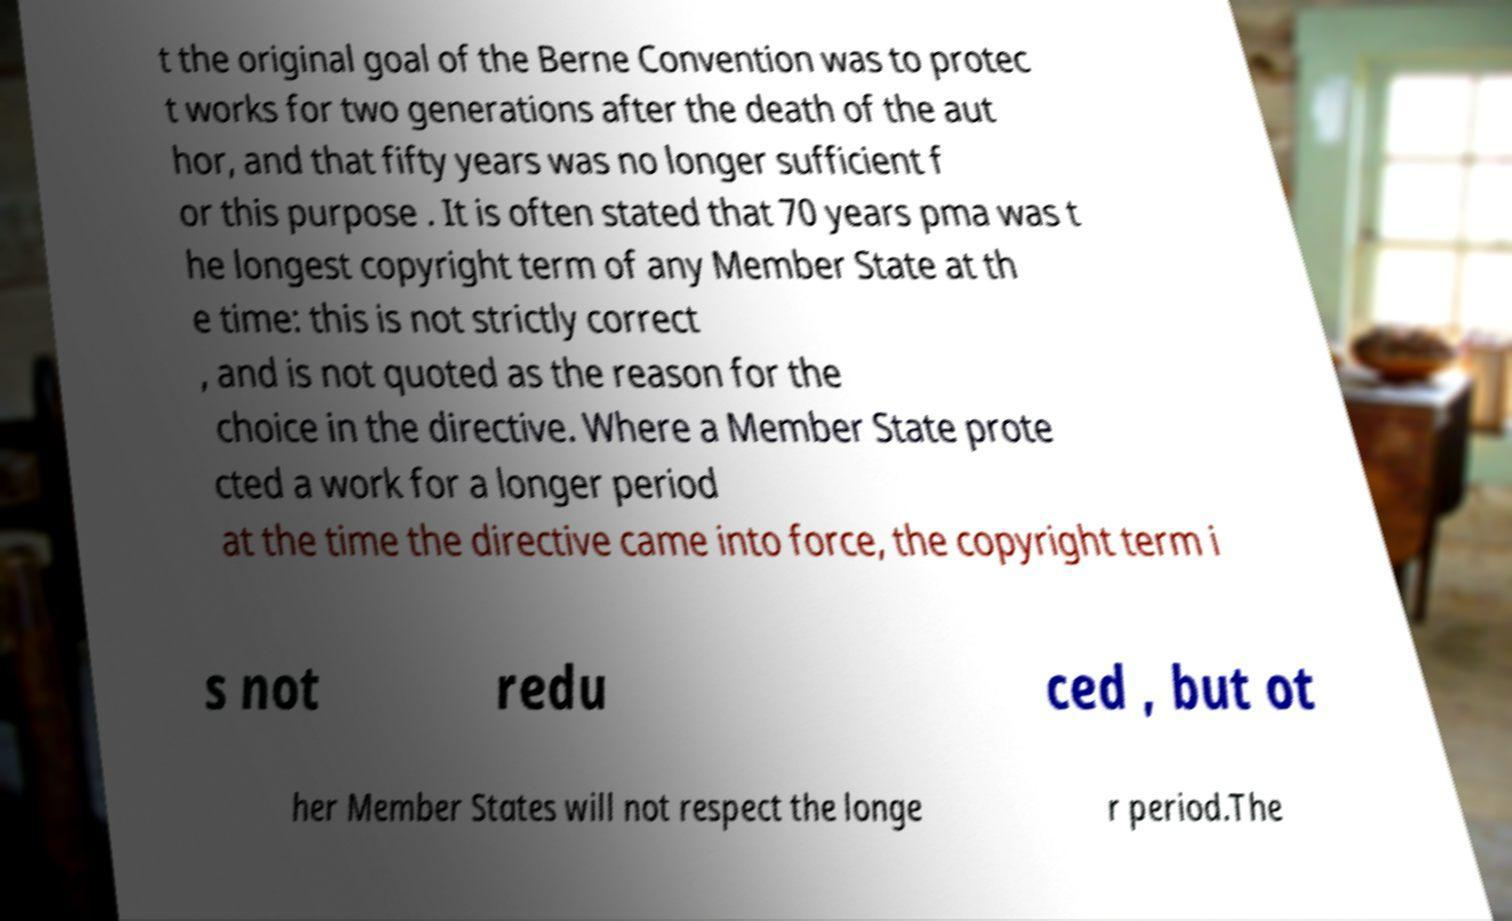For documentation purposes, I need the text within this image transcribed. Could you provide that? t the original goal of the Berne Convention was to protec t works for two generations after the death of the aut hor, and that fifty years was no longer sufficient f or this purpose . It is often stated that 70 years pma was t he longest copyright term of any Member State at th e time: this is not strictly correct , and is not quoted as the reason for the choice in the directive. Where a Member State prote cted a work for a longer period at the time the directive came into force, the copyright term i s not redu ced , but ot her Member States will not respect the longe r period.The 